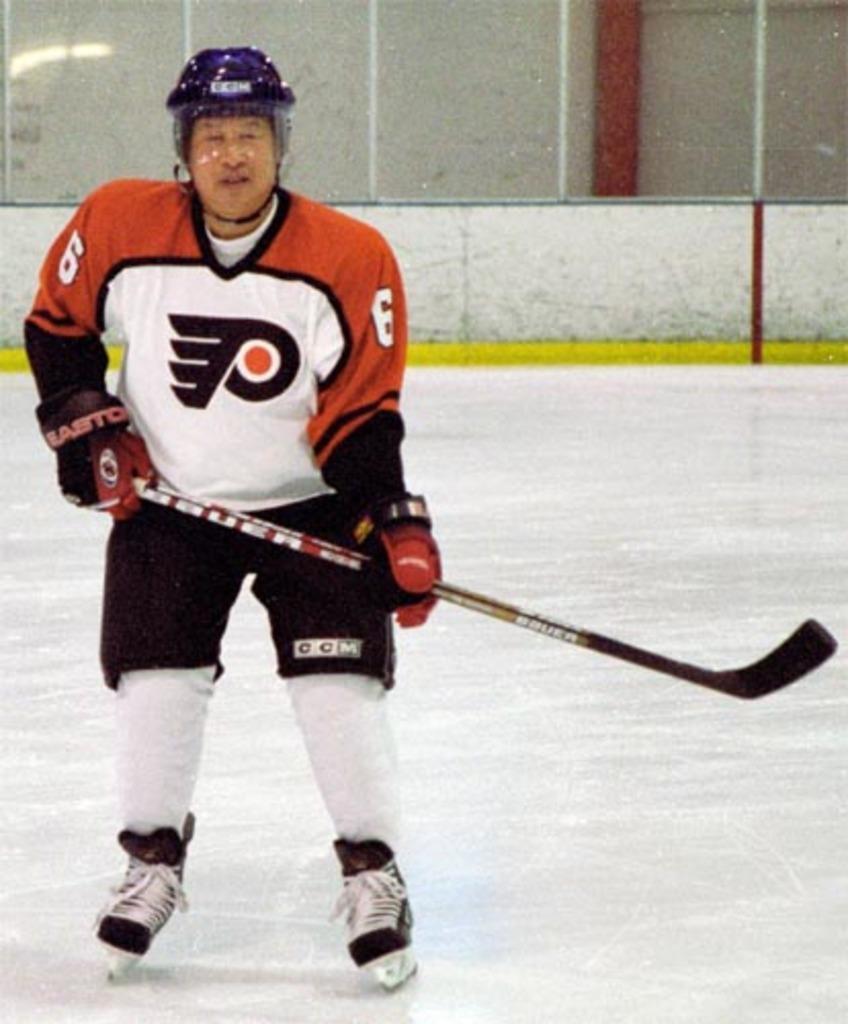In one or two sentences, can you explain what this image depicts? In this image I can see the person and the person is wearing white, orange and black color dress and holding the hockey stick, background I can see the wall in white color. 